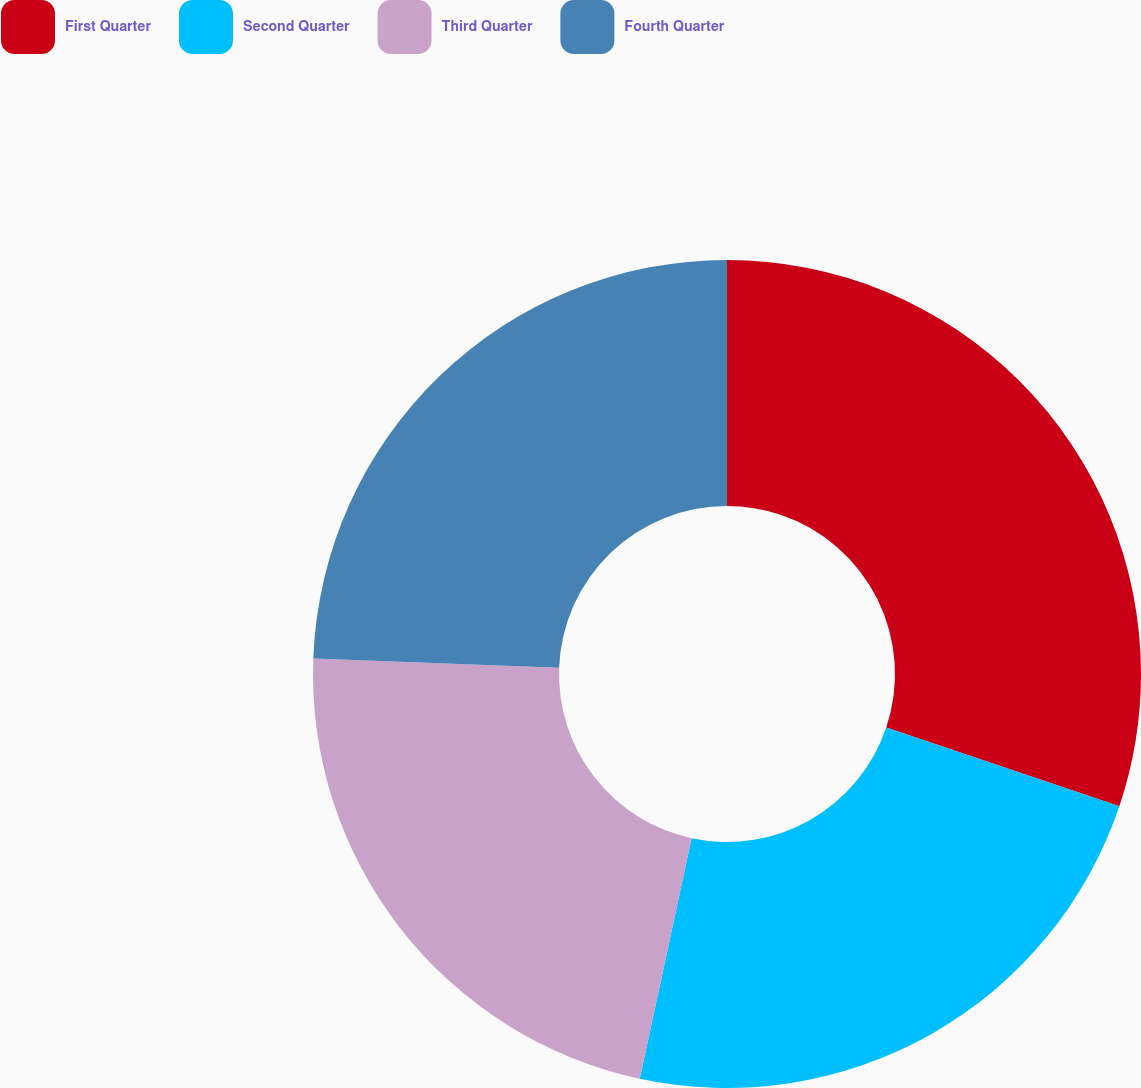Convert chart to OTSL. <chart><loc_0><loc_0><loc_500><loc_500><pie_chart><fcel>First Quarter<fcel>Second Quarter<fcel>Third Quarter<fcel>Fourth Quarter<nl><fcel>30.17%<fcel>23.21%<fcel>22.22%<fcel>24.4%<nl></chart> 